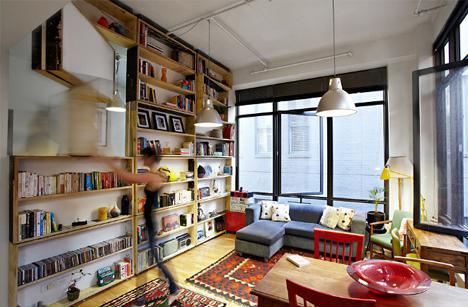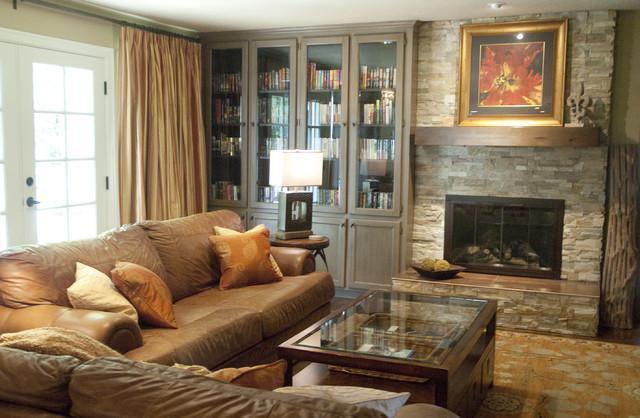The first image is the image on the left, the second image is the image on the right. Evaluate the accuracy of this statement regarding the images: "A round coffee table is by a chair with a footstool in front of a wall-filling bookcase.". Is it true? Answer yes or no. No. The first image is the image on the left, the second image is the image on the right. Assess this claim about the two images: "The center table in one of the images holds a container with blooming flowers.". Correct or not? Answer yes or no. No. 